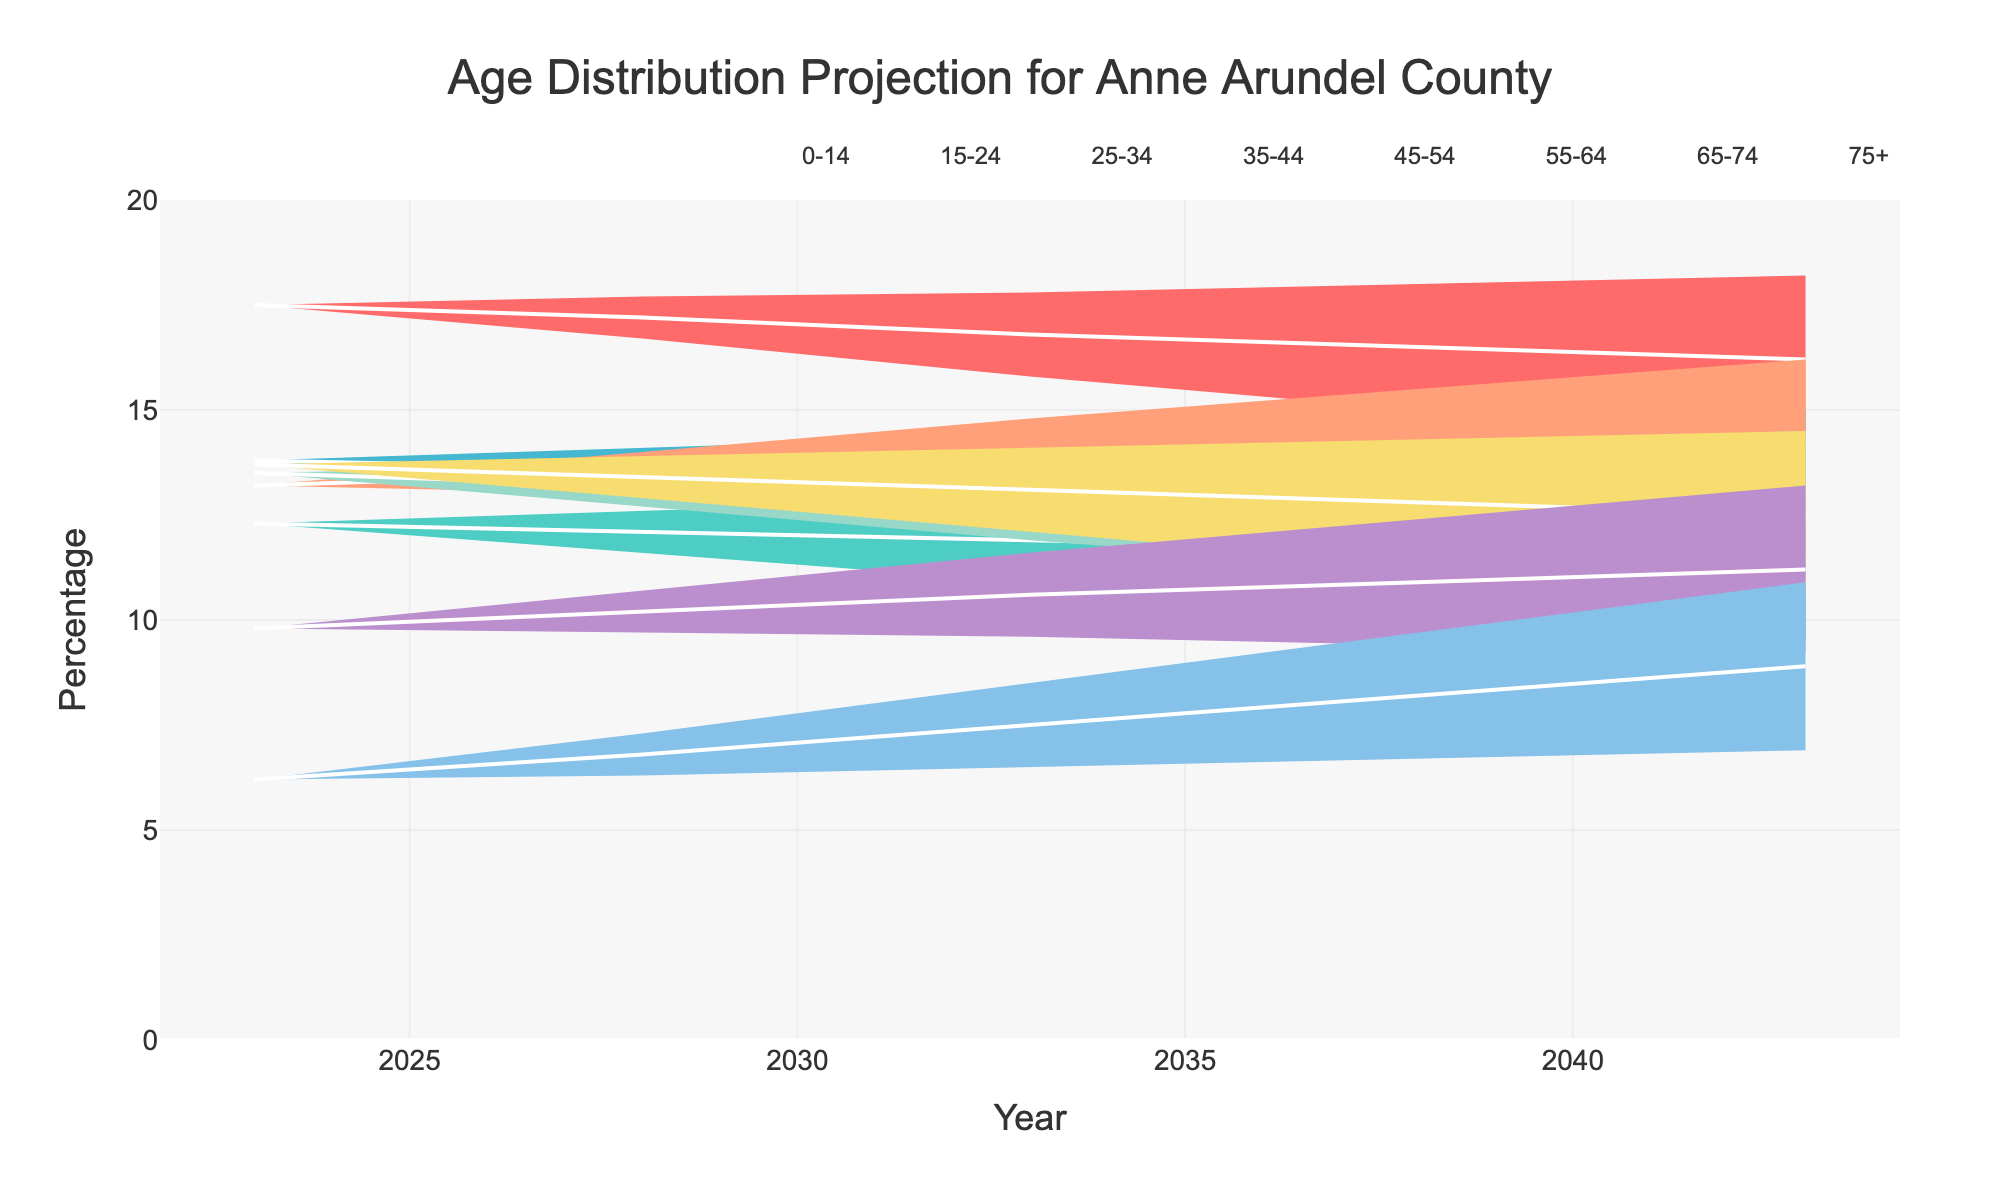what is the title of the figure? The title of the figure is usually located at the top center of the chart and is typically the largest text.
Answer: Age Distribution Projection for Anne Arundel County What is the percentage for the age group 0-14 in the year 2028? Locate the line that represents the age group 0-14 and follow it to the year 2028. Refer to the y-axis to find the percentage value.
Answer: 17.2% Which age group is projected to have the highest percentage in 2043? Compare the percentage values of all the age groups in the year 2043. The group with the highest value is the answer.
Answer: 0-14 How does the percentage for the age group 75+ change from 2023 to 2043? Compare the percentage for the age group 75+ in the years 2023 and 2043. Calculate the difference to understand the change.
Answer: Increases by 2.7% What is the average percentage for the age group 35-44 over the years given? Sum up the percentages of the age group 35-44 for all the years provided and then divide by the number of years.
Answer: 13.74% Which age group shows a steady decrease over time? Examine the trend lines for each age group and identify which one shows a consistent downward trend over all the years.
Answer: 0-14 Between 2023 and 2043, which age group sees the largest increase in percentage? Calculate the difference in percentage for each age group from 2023 to 2043. The group with the largest positive difference is the answer.
Answer: 75+ Is there any age group projected to have a stable percentage (little or no change) over the years? Look at the trend lines for each age group to see if any remain relatively stable, i.e., with minimal fluctuations.
Answer: 25-34 Which two age groups have relatively close percentages throughout all years? Identify the trend lines that are close to each other and maintain similar percentages across all years.
Answer: 55-64 and 45-54 